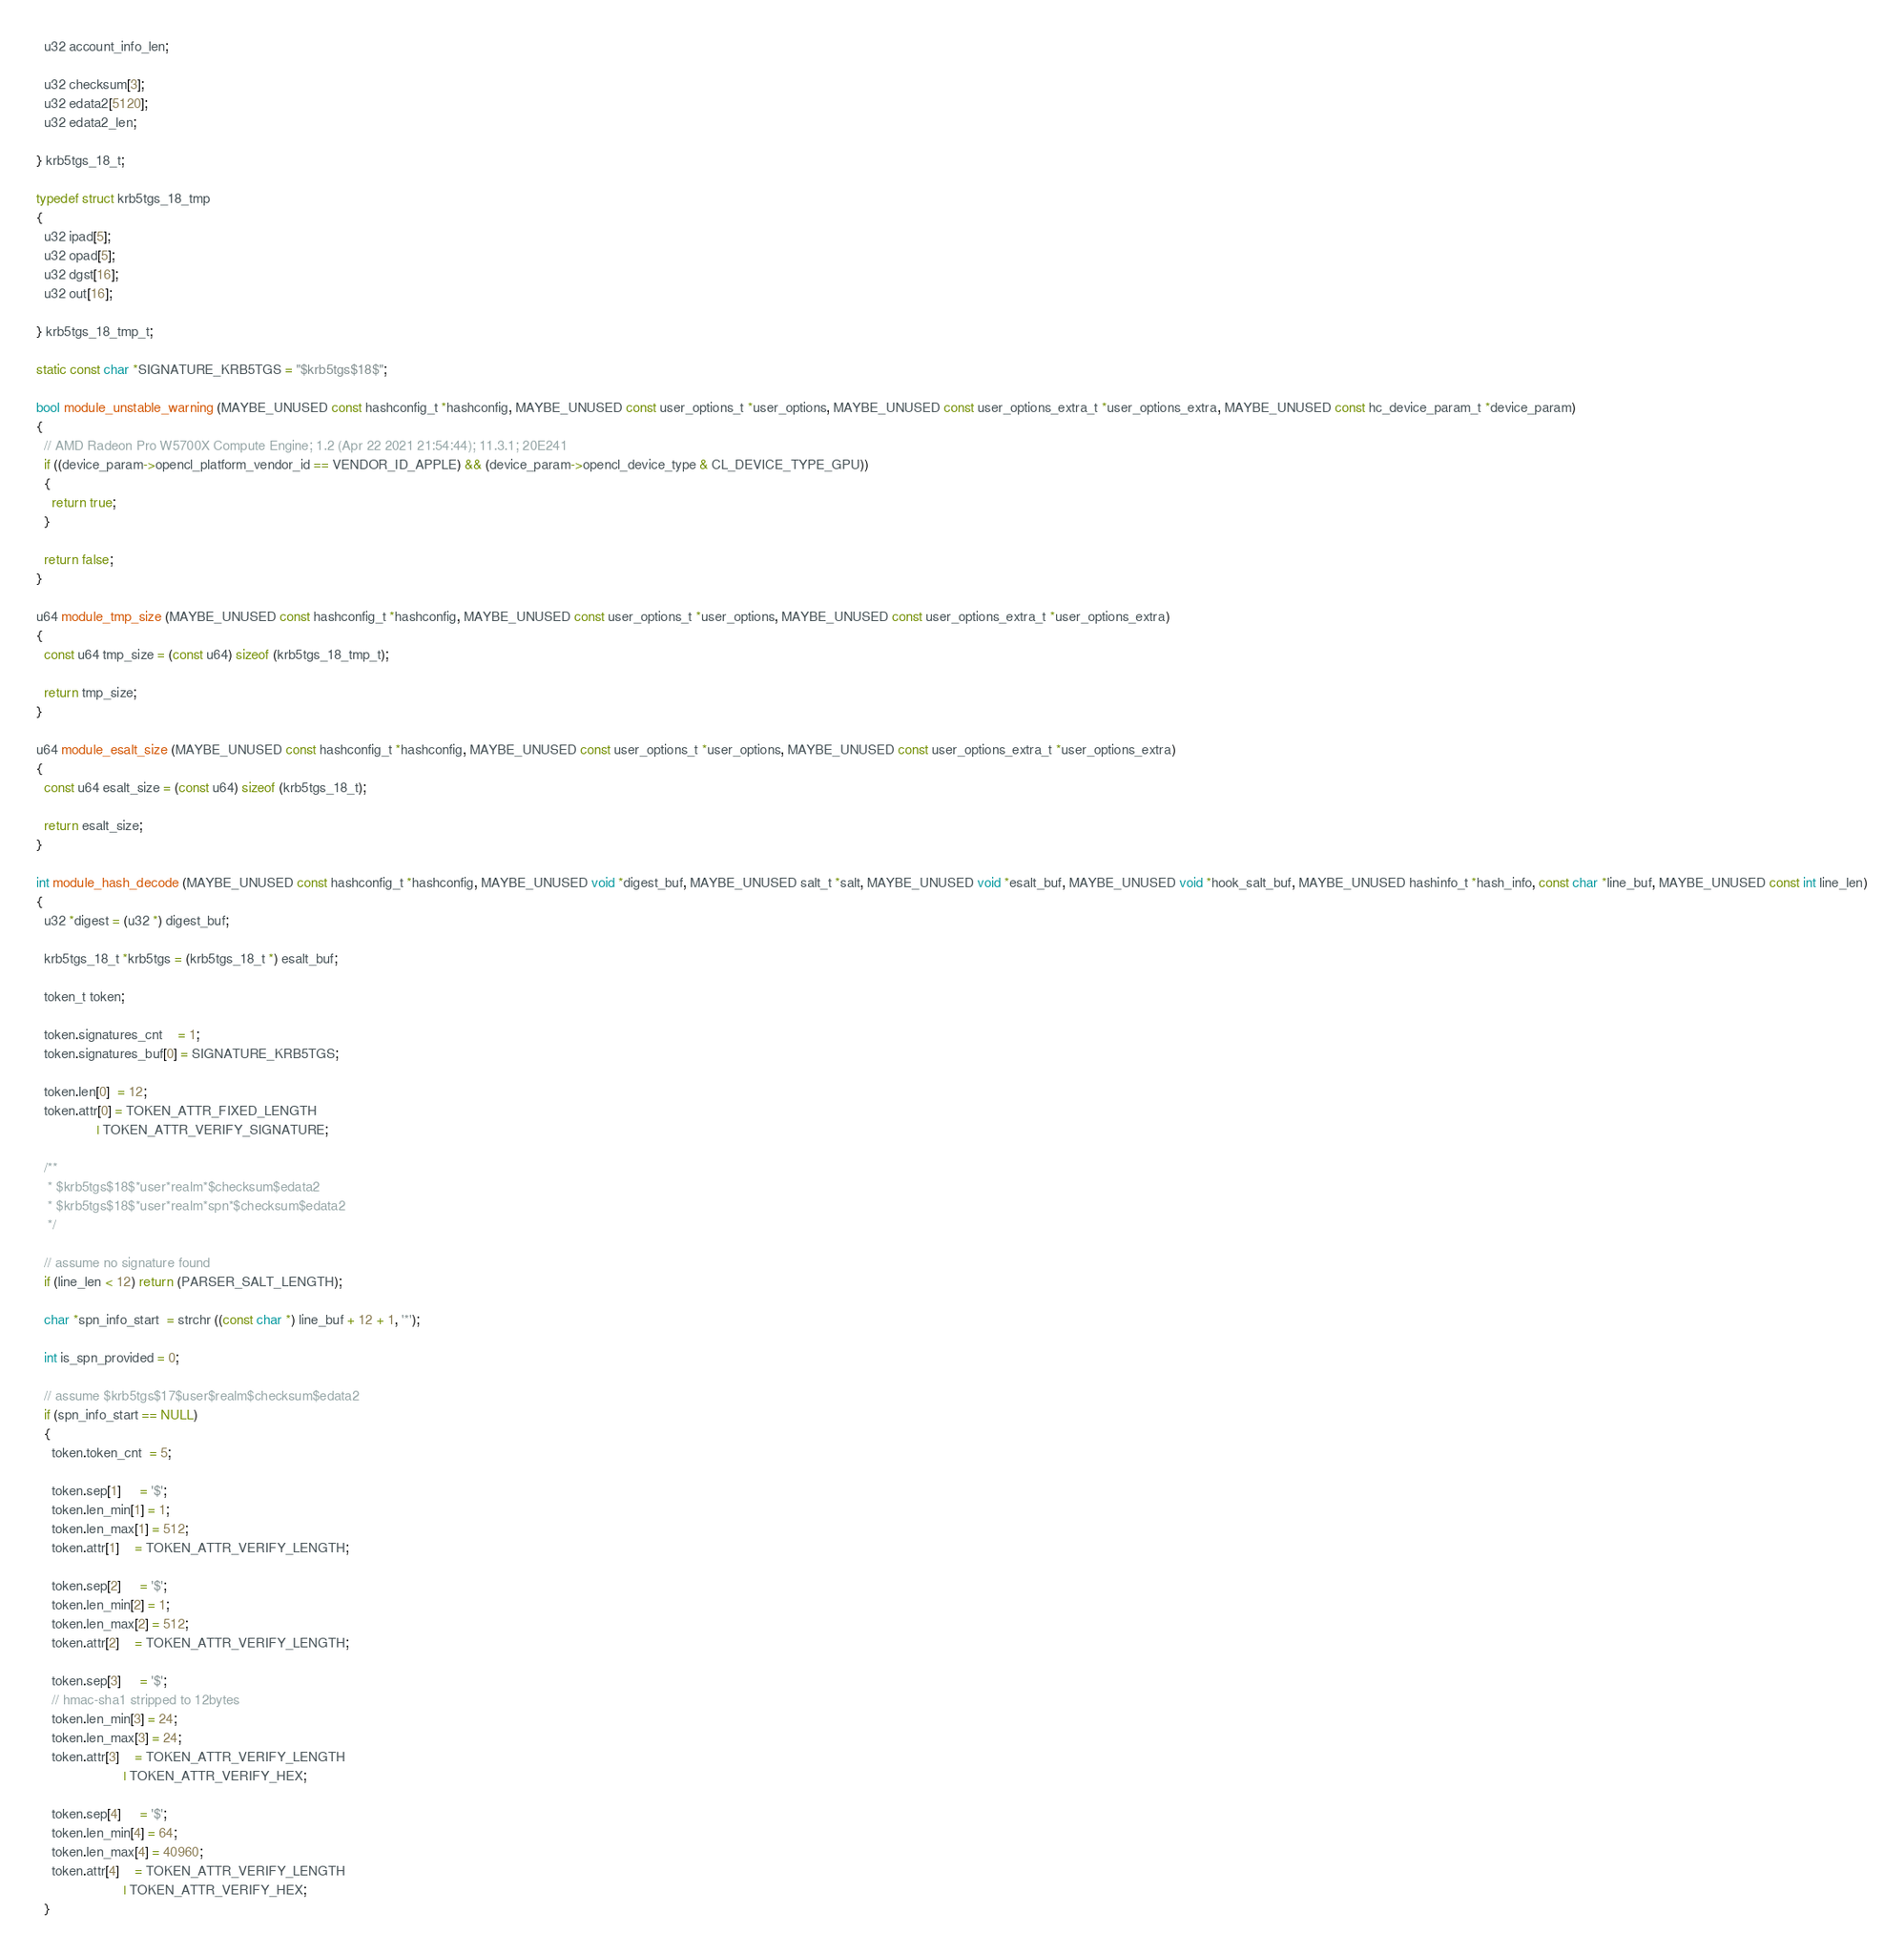<code> <loc_0><loc_0><loc_500><loc_500><_C_>  u32 account_info_len;

  u32 checksum[3];
  u32 edata2[5120];
  u32 edata2_len;

} krb5tgs_18_t;

typedef struct krb5tgs_18_tmp
{
  u32 ipad[5];
  u32 opad[5];
  u32 dgst[16];
  u32 out[16];

} krb5tgs_18_tmp_t;

static const char *SIGNATURE_KRB5TGS = "$krb5tgs$18$";

bool module_unstable_warning (MAYBE_UNUSED const hashconfig_t *hashconfig, MAYBE_UNUSED const user_options_t *user_options, MAYBE_UNUSED const user_options_extra_t *user_options_extra, MAYBE_UNUSED const hc_device_param_t *device_param)
{
  // AMD Radeon Pro W5700X Compute Engine; 1.2 (Apr 22 2021 21:54:44); 11.3.1; 20E241
  if ((device_param->opencl_platform_vendor_id == VENDOR_ID_APPLE) && (device_param->opencl_device_type & CL_DEVICE_TYPE_GPU))
  {
    return true;
  }

  return false;
}

u64 module_tmp_size (MAYBE_UNUSED const hashconfig_t *hashconfig, MAYBE_UNUSED const user_options_t *user_options, MAYBE_UNUSED const user_options_extra_t *user_options_extra)
{
  const u64 tmp_size = (const u64) sizeof (krb5tgs_18_tmp_t);

  return tmp_size;
}

u64 module_esalt_size (MAYBE_UNUSED const hashconfig_t *hashconfig, MAYBE_UNUSED const user_options_t *user_options, MAYBE_UNUSED const user_options_extra_t *user_options_extra)
{
  const u64 esalt_size = (const u64) sizeof (krb5tgs_18_t);

  return esalt_size;
}

int module_hash_decode (MAYBE_UNUSED const hashconfig_t *hashconfig, MAYBE_UNUSED void *digest_buf, MAYBE_UNUSED salt_t *salt, MAYBE_UNUSED void *esalt_buf, MAYBE_UNUSED void *hook_salt_buf, MAYBE_UNUSED hashinfo_t *hash_info, const char *line_buf, MAYBE_UNUSED const int line_len)
{
  u32 *digest = (u32 *) digest_buf;

  krb5tgs_18_t *krb5tgs = (krb5tgs_18_t *) esalt_buf;

  token_t token;

  token.signatures_cnt    = 1;
  token.signatures_buf[0] = SIGNATURE_KRB5TGS;

  token.len[0]  = 12;
  token.attr[0] = TOKEN_ATTR_FIXED_LENGTH
                | TOKEN_ATTR_VERIFY_SIGNATURE;

  /**
   * $krb5tgs$18$*user*realm*$checksum$edata2
   * $krb5tgs$18$*user*realm*spn*$checksum$edata2
   */

  // assume no signature found
  if (line_len < 12) return (PARSER_SALT_LENGTH);

  char *spn_info_start  = strchr ((const char *) line_buf + 12 + 1, '*');

  int is_spn_provided = 0;

  // assume $krb5tgs$17$user$realm$checksum$edata2
  if (spn_info_start == NULL)
  {
    token.token_cnt  = 5;

    token.sep[1]     = '$';
    token.len_min[1] = 1;
    token.len_max[1] = 512;
    token.attr[1]    = TOKEN_ATTR_VERIFY_LENGTH;

    token.sep[2]     = '$';
    token.len_min[2] = 1;
    token.len_max[2] = 512;
    token.attr[2]    = TOKEN_ATTR_VERIFY_LENGTH;

    token.sep[3]     = '$';
    // hmac-sha1 stripped to 12bytes
    token.len_min[3] = 24;
    token.len_max[3] = 24;
    token.attr[3]    = TOKEN_ATTR_VERIFY_LENGTH
                       | TOKEN_ATTR_VERIFY_HEX;

    token.sep[4]     = '$';
    token.len_min[4] = 64;
    token.len_max[4] = 40960;
    token.attr[4]    = TOKEN_ATTR_VERIFY_LENGTH
                       | TOKEN_ATTR_VERIFY_HEX;
  }</code> 